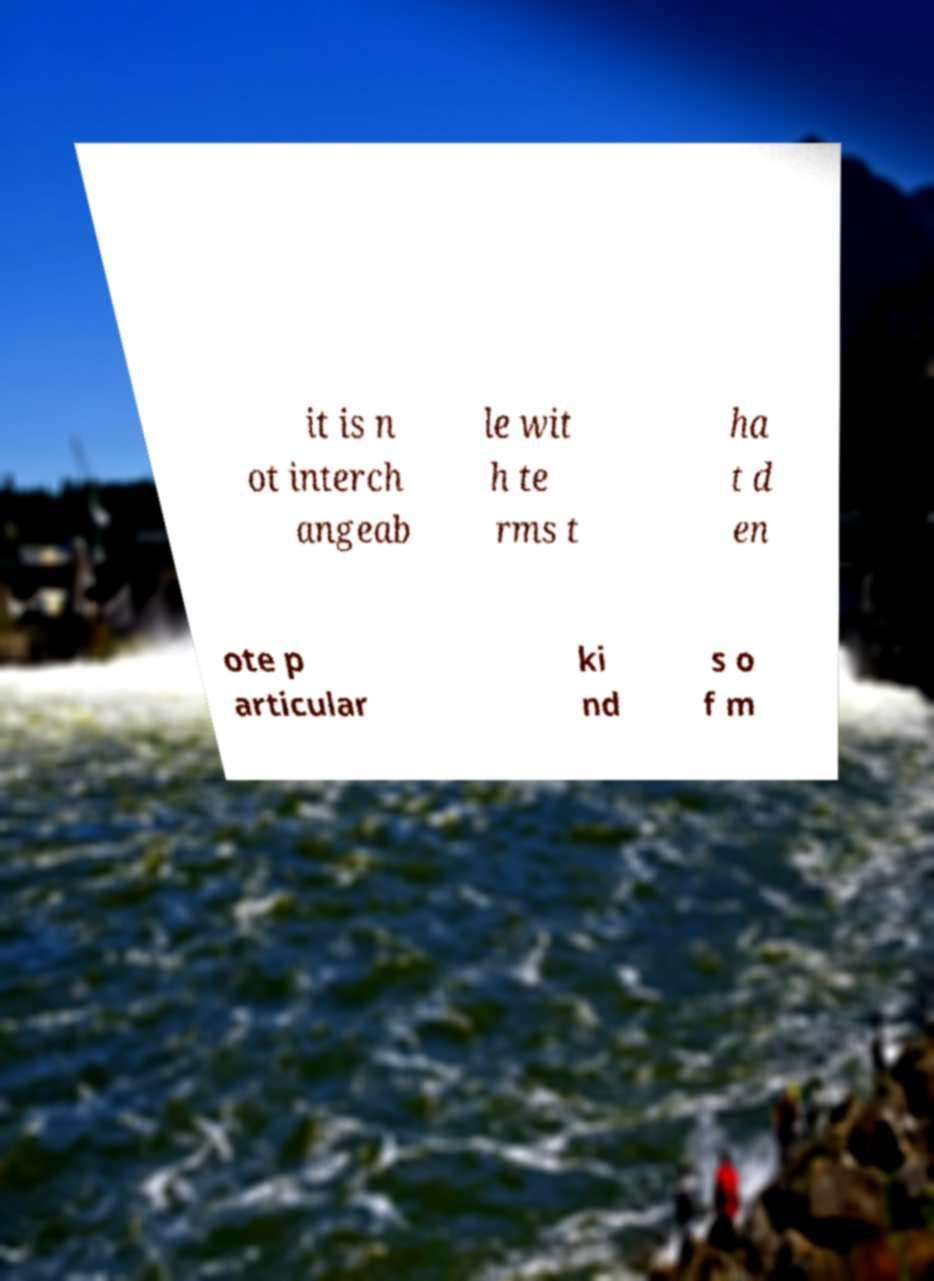Could you assist in decoding the text presented in this image and type it out clearly? it is n ot interch angeab le wit h te rms t ha t d en ote p articular ki nd s o f m 